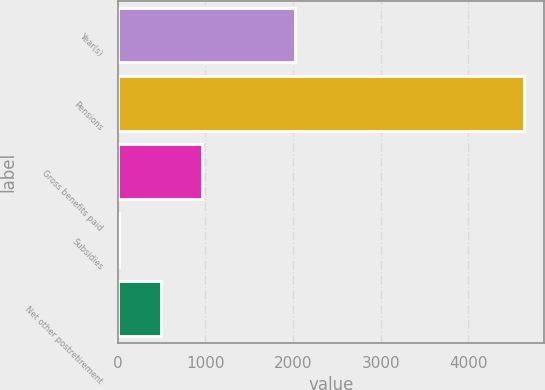<chart> <loc_0><loc_0><loc_500><loc_500><bar_chart><fcel>Year(s)<fcel>Pensions<fcel>Gross benefits paid<fcel>Subsidies<fcel>Net other postretirement<nl><fcel>2022<fcel>4631<fcel>960.4<fcel>17<fcel>499<nl></chart> 